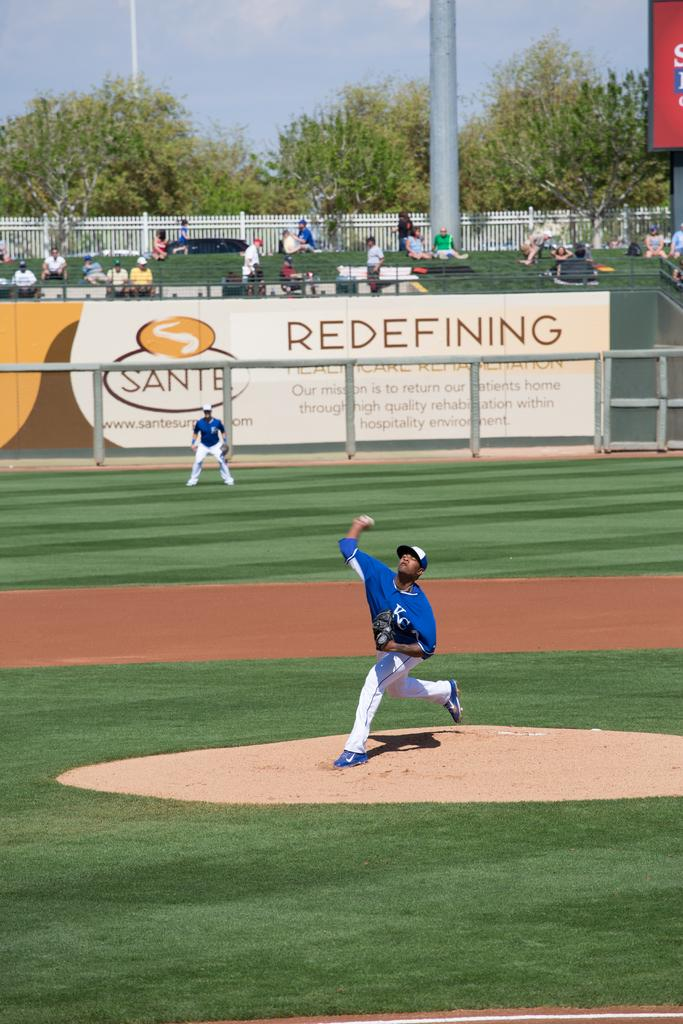<image>
Give a short and clear explanation of the subsequent image. A pitcher throws a pitch in fron of a Sante Redefining sign. 